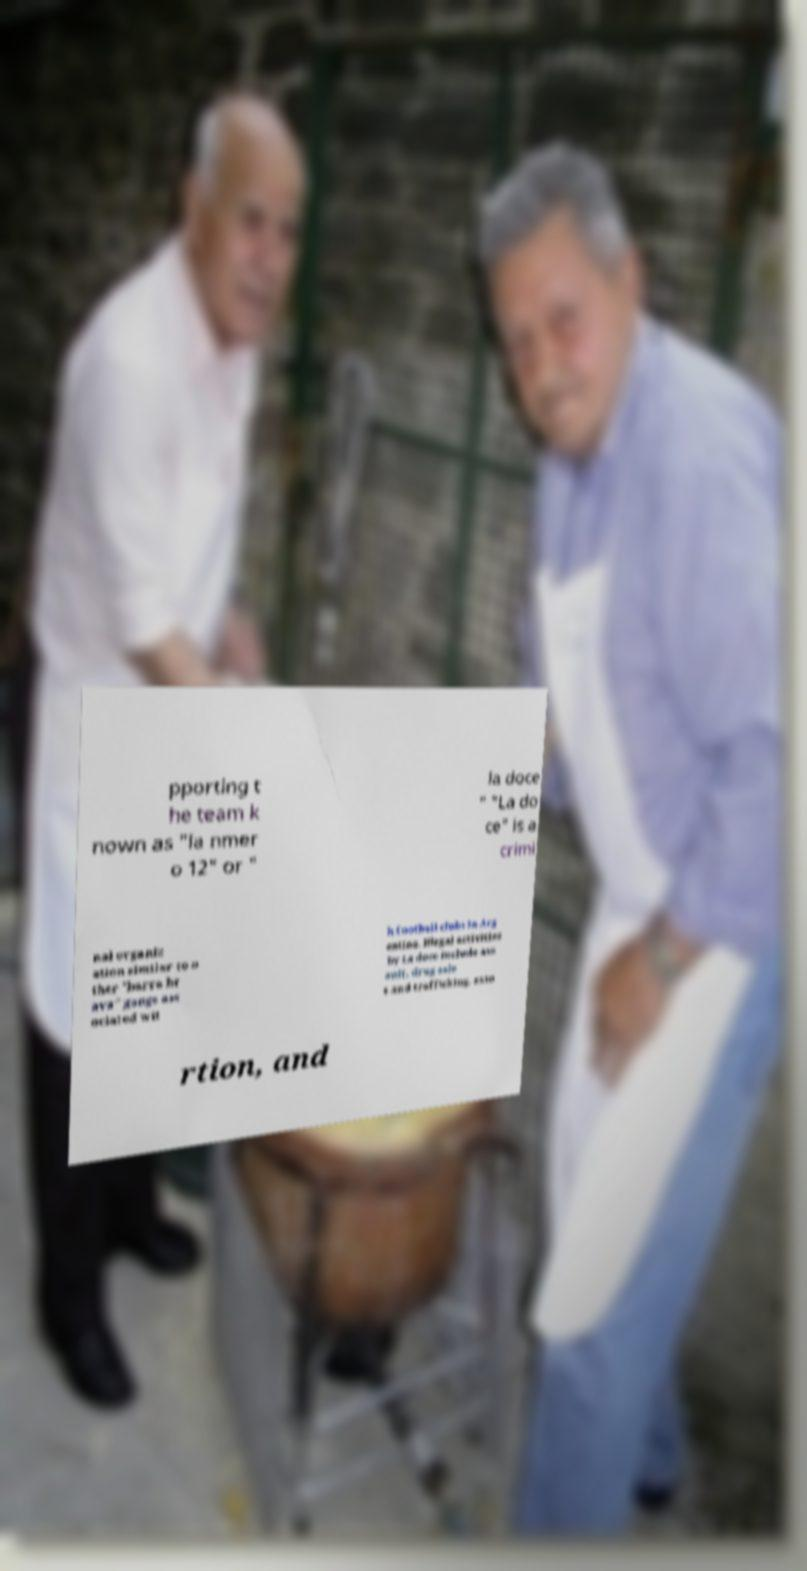Please identify and transcribe the text found in this image. pporting t he team k nown as "la nmer o 12" or " la doce " "La do ce" is a crimi nal organiz ation similar to o ther "barra br ava" gangs ass ociated wit h football clubs in Arg entina. Illegal activities by La doce include ass ault, drug sale s and trafficking, exto rtion, and 